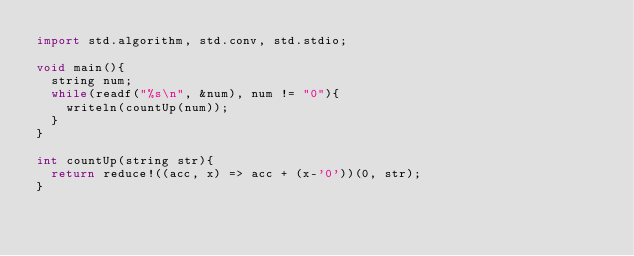<code> <loc_0><loc_0><loc_500><loc_500><_D_>import std.algorithm, std.conv, std.stdio;

void main(){
	string num;
	while(readf("%s\n", &num), num != "0"){
		writeln(countUp(num));
	} 
}

int countUp(string str){
	return reduce!((acc, x) => acc + (x-'0'))(0, str);
}</code> 